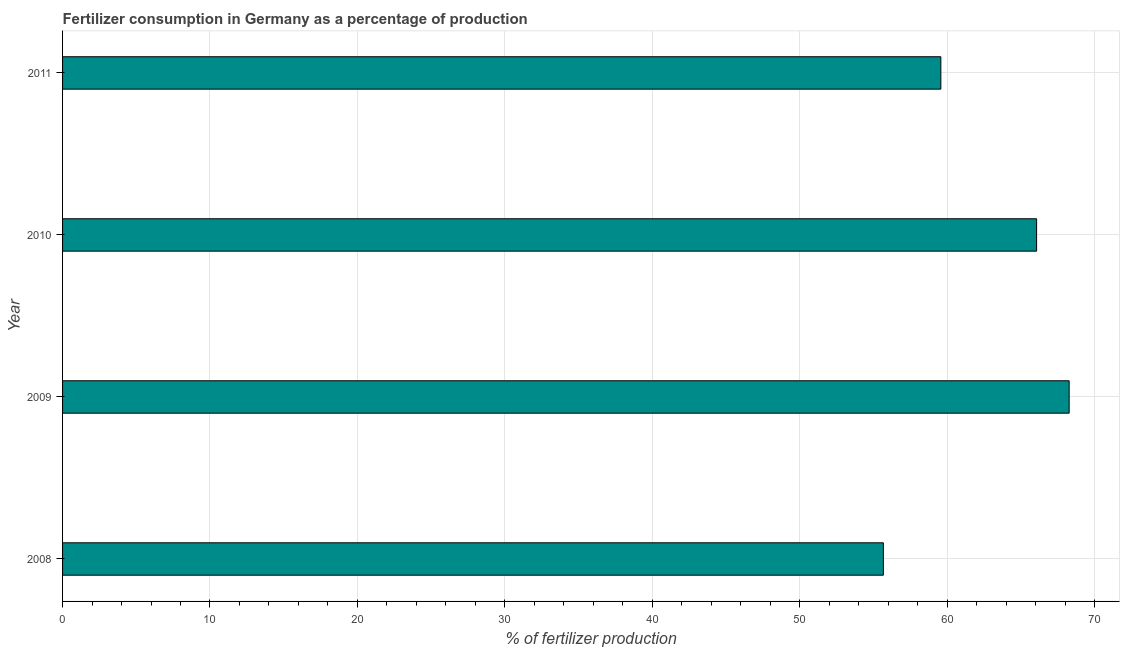Does the graph contain grids?
Give a very brief answer. Yes. What is the title of the graph?
Provide a short and direct response. Fertilizer consumption in Germany as a percentage of production. What is the label or title of the X-axis?
Provide a succinct answer. % of fertilizer production. What is the label or title of the Y-axis?
Keep it short and to the point. Year. What is the amount of fertilizer consumption in 2010?
Offer a very short reply. 66.07. Across all years, what is the maximum amount of fertilizer consumption?
Your answer should be compact. 68.28. Across all years, what is the minimum amount of fertilizer consumption?
Provide a short and direct response. 55.68. What is the sum of the amount of fertilizer consumption?
Your response must be concise. 249.61. What is the difference between the amount of fertilizer consumption in 2008 and 2010?
Your response must be concise. -10.39. What is the average amount of fertilizer consumption per year?
Offer a very short reply. 62.4. What is the median amount of fertilizer consumption?
Your answer should be compact. 62.83. What is the ratio of the amount of fertilizer consumption in 2009 to that in 2011?
Ensure brevity in your answer.  1.15. Is the amount of fertilizer consumption in 2008 less than that in 2011?
Your answer should be very brief. Yes. What is the difference between the highest and the second highest amount of fertilizer consumption?
Offer a terse response. 2.21. Is the sum of the amount of fertilizer consumption in 2008 and 2009 greater than the maximum amount of fertilizer consumption across all years?
Keep it short and to the point. Yes. Are all the bars in the graph horizontal?
Offer a terse response. Yes. Are the values on the major ticks of X-axis written in scientific E-notation?
Your answer should be very brief. No. What is the % of fertilizer production of 2008?
Give a very brief answer. 55.68. What is the % of fertilizer production in 2009?
Your response must be concise. 68.28. What is the % of fertilizer production of 2010?
Ensure brevity in your answer.  66.07. What is the % of fertilizer production in 2011?
Your answer should be compact. 59.58. What is the difference between the % of fertilizer production in 2008 and 2009?
Ensure brevity in your answer.  -12.6. What is the difference between the % of fertilizer production in 2008 and 2010?
Provide a short and direct response. -10.39. What is the difference between the % of fertilizer production in 2008 and 2011?
Offer a terse response. -3.9. What is the difference between the % of fertilizer production in 2009 and 2010?
Offer a very short reply. 2.21. What is the difference between the % of fertilizer production in 2009 and 2011?
Keep it short and to the point. 8.7. What is the difference between the % of fertilizer production in 2010 and 2011?
Your answer should be very brief. 6.5. What is the ratio of the % of fertilizer production in 2008 to that in 2009?
Ensure brevity in your answer.  0.81. What is the ratio of the % of fertilizer production in 2008 to that in 2010?
Make the answer very short. 0.84. What is the ratio of the % of fertilizer production in 2008 to that in 2011?
Make the answer very short. 0.94. What is the ratio of the % of fertilizer production in 2009 to that in 2010?
Give a very brief answer. 1.03. What is the ratio of the % of fertilizer production in 2009 to that in 2011?
Keep it short and to the point. 1.15. What is the ratio of the % of fertilizer production in 2010 to that in 2011?
Ensure brevity in your answer.  1.11. 